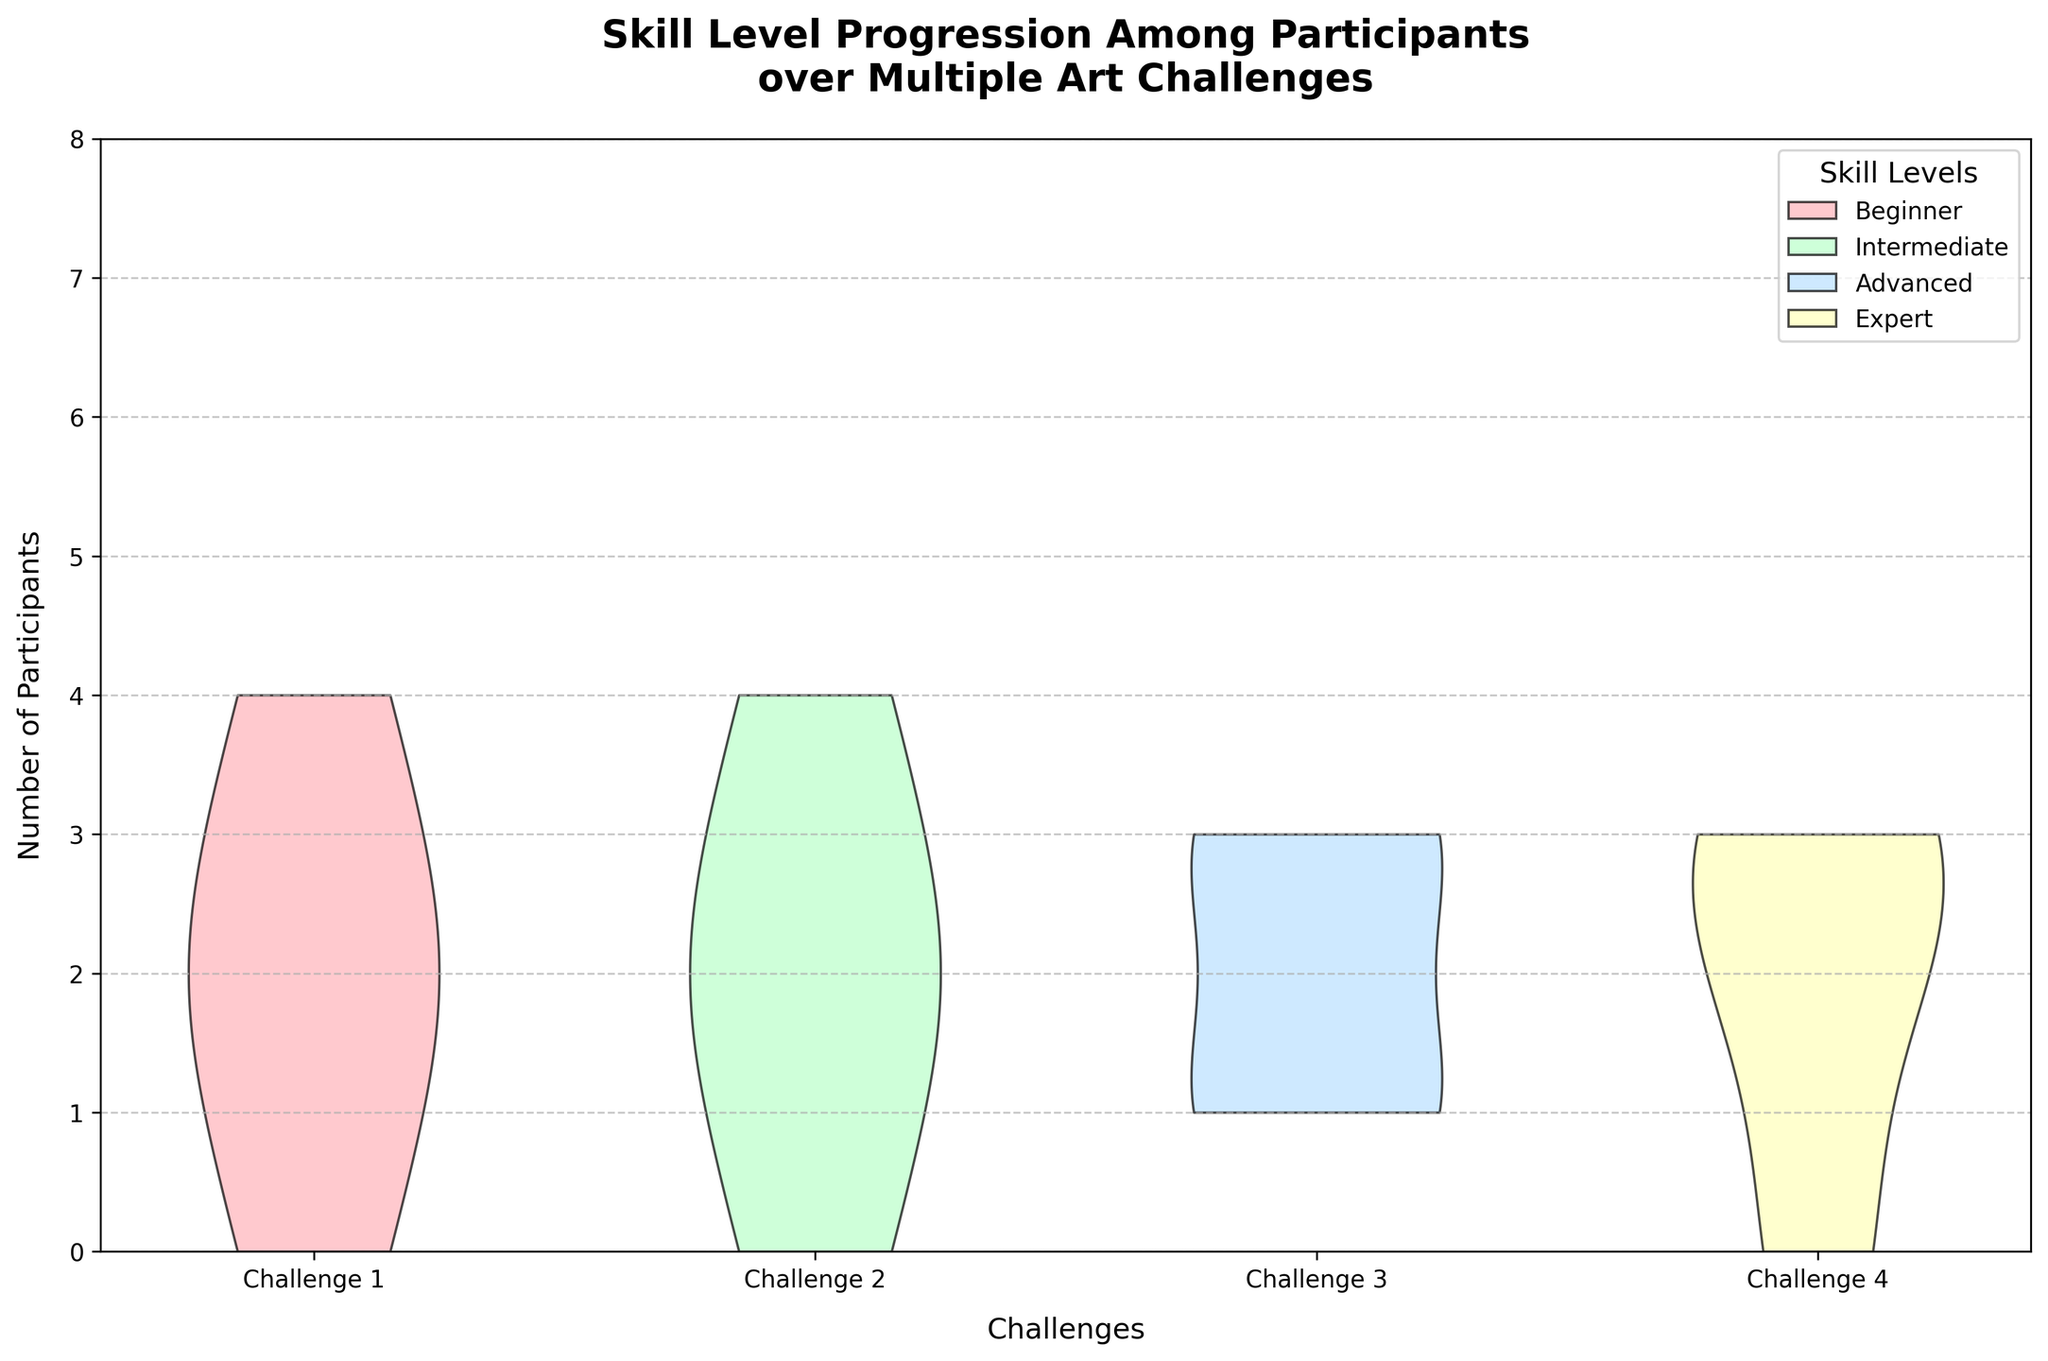Which challenge has the highest number of participants? The challenge with the greatest height of the violin plots would indicate the highest number of participants. From the visual inspection, all challenges seem to have similar participation levels, but Challenge 4 appears a bit taller overall.
Answer: Challenge 4 What color represents the Intermediate skill level? The violin plots use distinct colors for each skill level. The Intermediate level is the second violin plot from the bottom for each challenge, typically colored pale green.
Answer: Pale green How many participants reached the Expert skill level by Challenge 4? The violin for Challenge 4 shows the "Expert" category, which is the top-most section in dark yellow. Counting the heights, there are visible participants in this section.
Answer: 2 How does the progression of participants differ from Beginner to Advanced across the challenges? By observing the height and width of the sections within each violin, one sees a transition where Beginner participants decrease while Intermediate and Advanced participants increase, with some reaching Expert by Challenge 4.
Answer: Beginners decrease, Intermediate increases, and some reach Advanced and Expert Which skill level has the most participants in Challenge 3? In Challenge 3, the widest section of the violin plot correlates with the highest number of participants. The "Intermediate" level seems to have the widest section.
Answer: Intermediate Is there any skill level that has consistent participants throughout all challenges? The "Advanced" skill level appears relatively consistent, seen in fairly uniform widths and heights across all segments it appears in challenges 1 to 4.
Answer: Advanced By Challenge 4, which skill level shows the greatest improvement in terms of participant count? Starting from Challenge 1, observe which section of the violins grows the most by Challenge 4. The "Advanced" group grows significantly, indicating improvement.
Answer: Advanced Compare the number of participants in the Beginner category between Challenge 1 and Challenge 4. Compare the height of the "Beginner" section in Challenge 1 and Challenge 4. The "Beginner" section is higher in Challenge 1 and much lower by Challenge 4.
Answer: Higher in Challenge 1, lower in Challenge 4 How do Expert level participants change from Challenge 1 to Challenge 4? Inspect the presence of the top-most section for each Challenge. "Expert" begins appearing only in Challenge 3 and persists in Challenge 4, showing an increase.
Answer: None in Challenge 1, increases by Challenge 4 